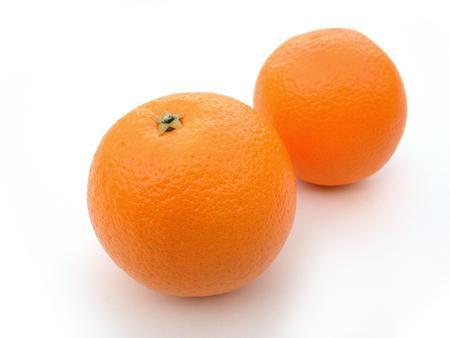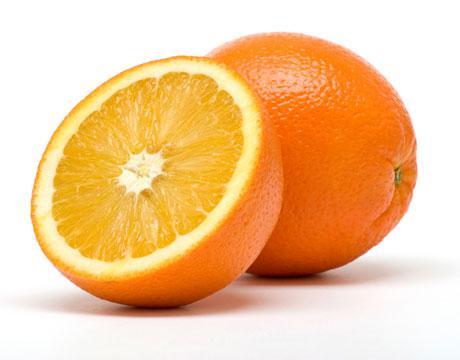The first image is the image on the left, the second image is the image on the right. Analyze the images presented: Is the assertion "There are three whole oranges and a half an orange in the image pair." valid? Answer yes or no. Yes. The first image is the image on the left, the second image is the image on the right. Analyze the images presented: Is the assertion "The right image contains at least one orange that is sliced in half." valid? Answer yes or no. Yes. 